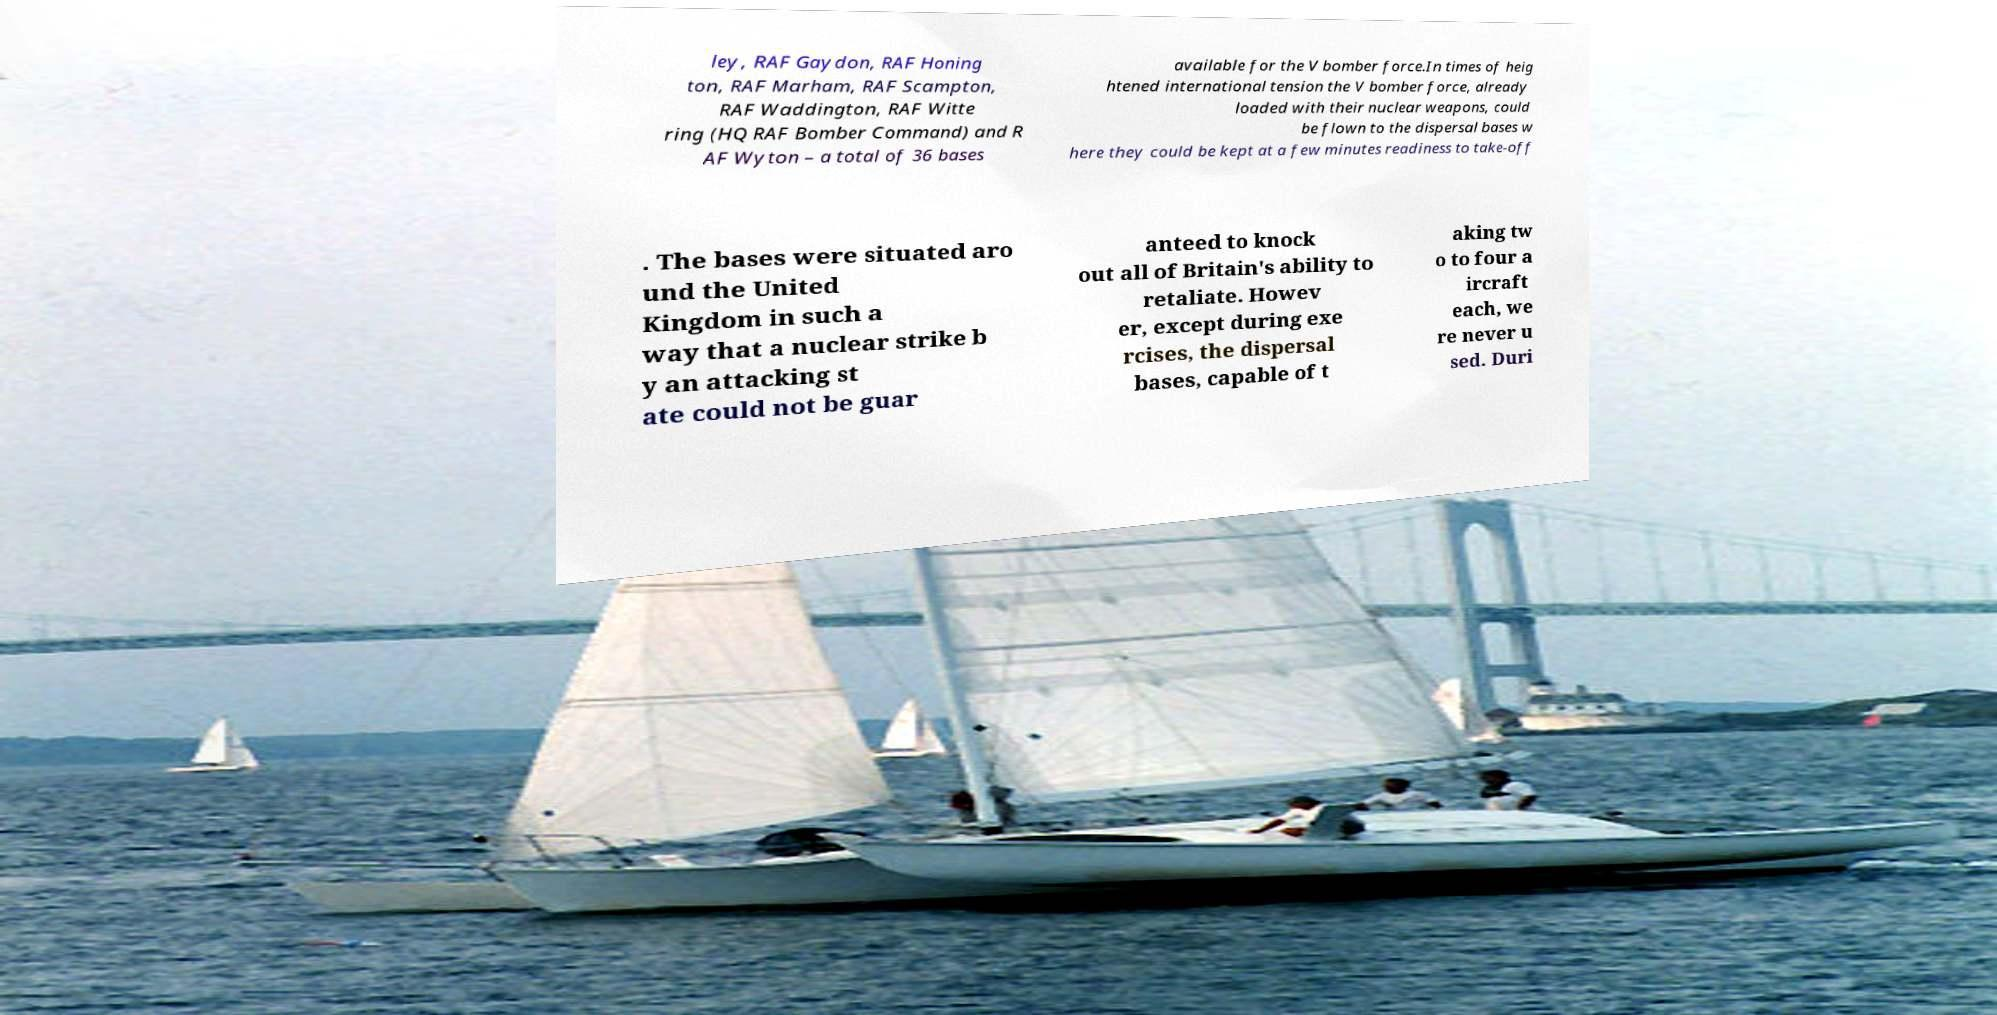Please identify and transcribe the text found in this image. ley, RAF Gaydon, RAF Honing ton, RAF Marham, RAF Scampton, RAF Waddington, RAF Witte ring (HQ RAF Bomber Command) and R AF Wyton – a total of 36 bases available for the V bomber force.In times of heig htened international tension the V bomber force, already loaded with their nuclear weapons, could be flown to the dispersal bases w here they could be kept at a few minutes readiness to take-off . The bases were situated aro und the United Kingdom in such a way that a nuclear strike b y an attacking st ate could not be guar anteed to knock out all of Britain's ability to retaliate. Howev er, except during exe rcises, the dispersal bases, capable of t aking tw o to four a ircraft each, we re never u sed. Duri 